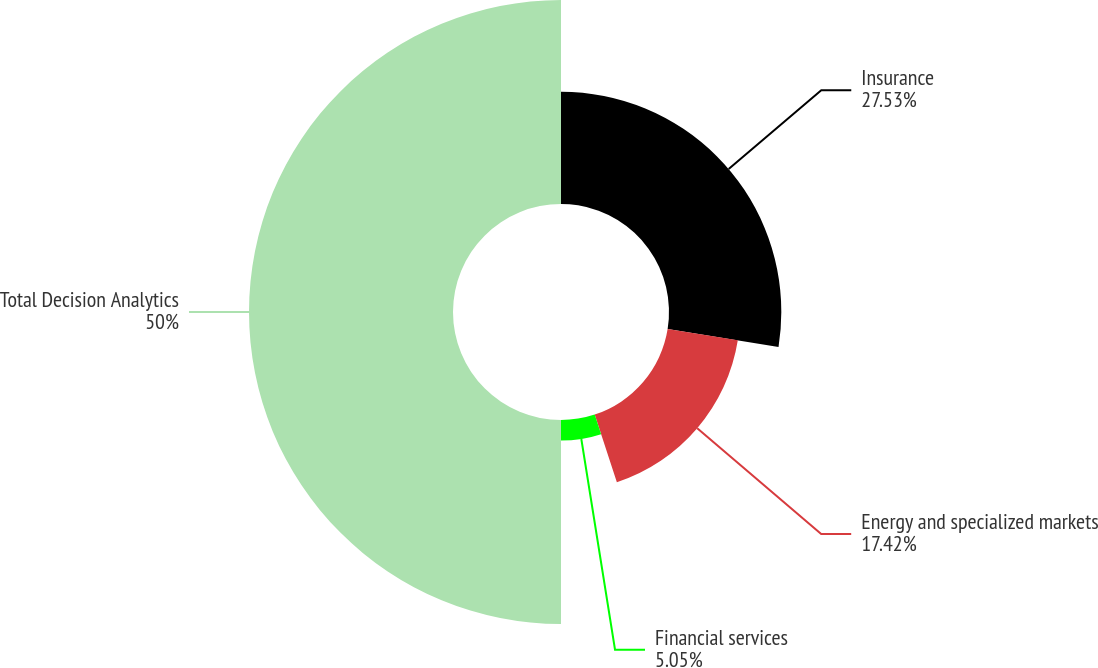Convert chart to OTSL. <chart><loc_0><loc_0><loc_500><loc_500><pie_chart><fcel>Insurance<fcel>Energy and specialized markets<fcel>Financial services<fcel>Total Decision Analytics<nl><fcel>27.53%<fcel>17.42%<fcel>5.05%<fcel>50.0%<nl></chart> 